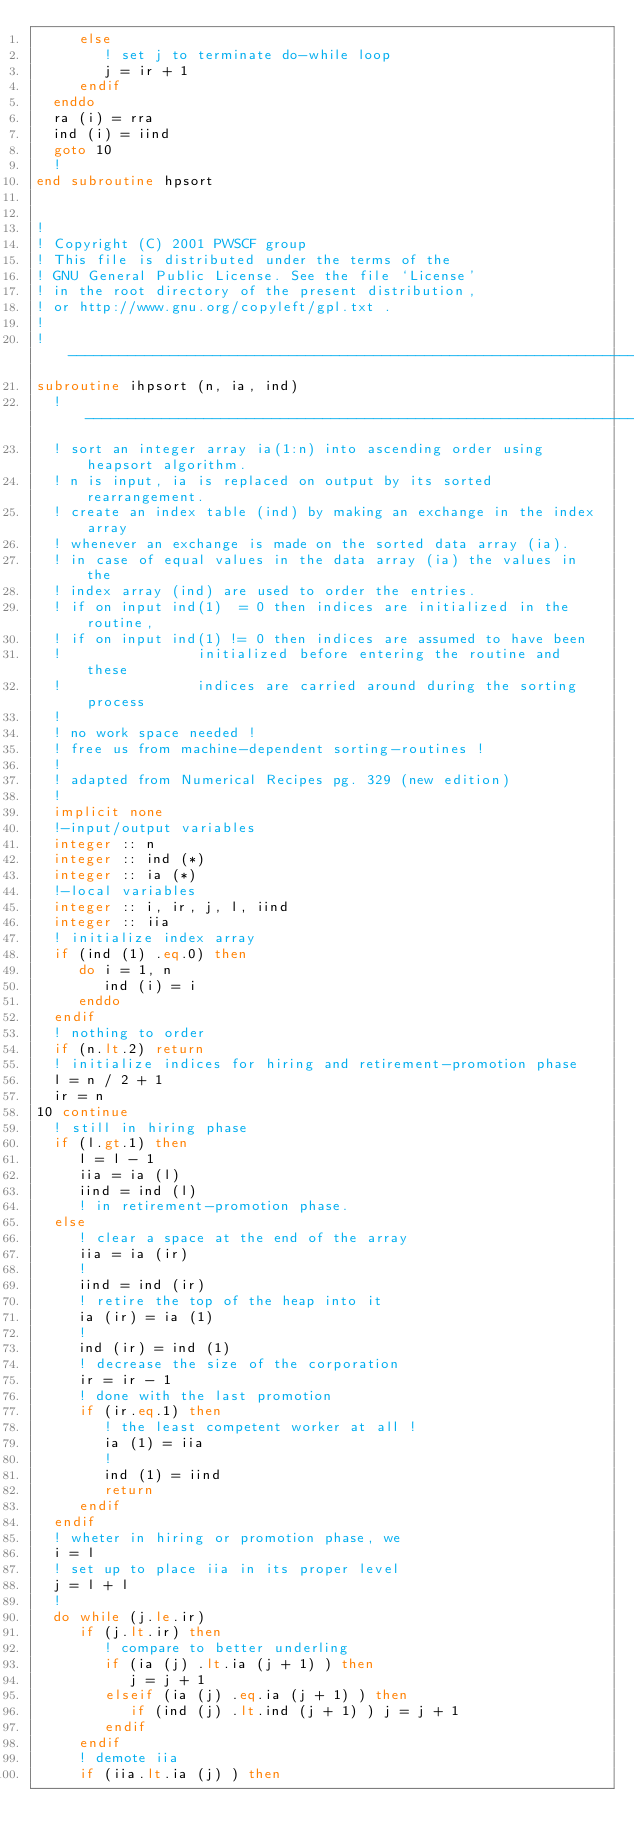Convert code to text. <code><loc_0><loc_0><loc_500><loc_500><_FORTRAN_>     else  
        ! set j to terminate do-while loop
        j = ir + 1  
     endif
  enddo
  ra (i) = rra  
  ind (i) = iind  
  goto 10  
  !
end subroutine hpsort


!
! Copyright (C) 2001 PWSCF group
! This file is distributed under the terms of the
! GNU General Public License. See the file `License'
! in the root directory of the present distribution,
! or http://www.gnu.org/copyleft/gpl.txt .
!
!---------------------------------------------------------------------
subroutine ihpsort (n, ia, ind)  
  !---------------------------------------------------------------------
  ! sort an integer array ia(1:n) into ascending order using heapsort algorithm.
  ! n is input, ia is replaced on output by its sorted rearrangement.
  ! create an index table (ind) by making an exchange in the index array
  ! whenever an exchange is made on the sorted data array (ia).
  ! in case of equal values in the data array (ia) the values in the
  ! index array (ind) are used to order the entries.
  ! if on input ind(1)  = 0 then indices are initialized in the routine,
  ! if on input ind(1) != 0 then indices are assumed to have been
  !                initialized before entering the routine and these
  !                indices are carried around during the sorting process
  !
  ! no work space needed !
  ! free us from machine-dependent sorting-routines !
  !
  ! adapted from Numerical Recipes pg. 329 (new edition)
  !
  implicit none  
  !-input/output variables
  integer :: n  
  integer :: ind (*)  
  integer :: ia (*)  
  !-local variables
  integer :: i, ir, j, l, iind  
  integer :: iia  
  ! initialize index array
  if (ind (1) .eq.0) then  
     do i = 1, n  
        ind (i) = i  
     enddo
  endif
  ! nothing to order
  if (n.lt.2) return  
  ! initialize indices for hiring and retirement-promotion phase
  l = n / 2 + 1  
  ir = n  
10 continue  
  ! still in hiring phase
  if (l.gt.1) then  
     l = l - 1  
     iia = ia (l)  
     iind = ind (l)  
     ! in retirement-promotion phase.
  else  
     ! clear a space at the end of the array
     iia = ia (ir)  
     !
     iind = ind (ir)  
     ! retire the top of the heap into it
     ia (ir) = ia (1)  
     !
     ind (ir) = ind (1)  
     ! decrease the size of the corporation
     ir = ir - 1  
     ! done with the last promotion
     if (ir.eq.1) then  
        ! the least competent worker at all !
        ia (1) = iia  
        !
        ind (1) = iind  
        return  
     endif
  endif
  ! wheter in hiring or promotion phase, we
  i = l  
  ! set up to place iia in its proper level
  j = l + l  
  !
  do while (j.le.ir)  
     if (j.lt.ir) then  
        ! compare to better underling
        if (ia (j) .lt.ia (j + 1) ) then  
           j = j + 1  
        elseif (ia (j) .eq.ia (j + 1) ) then  
           if (ind (j) .lt.ind (j + 1) ) j = j + 1  
        endif
     endif
     ! demote iia
     if (iia.lt.ia (j) ) then  </code> 